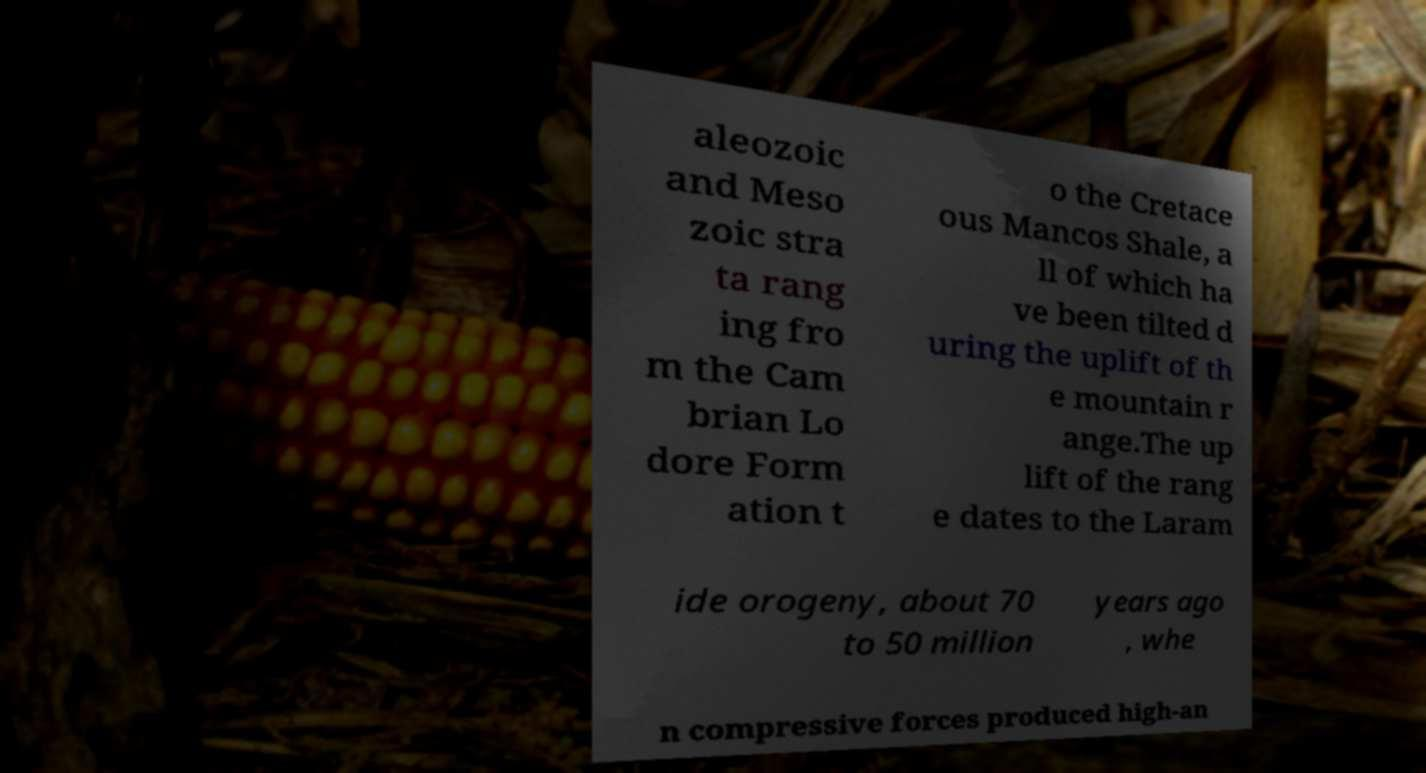I need the written content from this picture converted into text. Can you do that? aleozoic and Meso zoic stra ta rang ing fro m the Cam brian Lo dore Form ation t o the Cretace ous Mancos Shale, a ll of which ha ve been tilted d uring the uplift of th e mountain r ange.The up lift of the rang e dates to the Laram ide orogeny, about 70 to 50 million years ago , whe n compressive forces produced high-an 